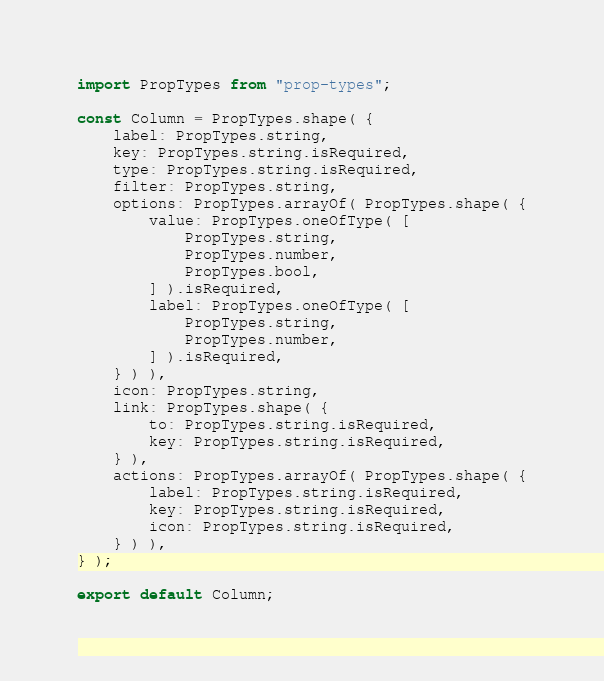Convert code to text. <code><loc_0><loc_0><loc_500><loc_500><_JavaScript_>import PropTypes from "prop-types";

const Column = PropTypes.shape( {
    label: PropTypes.string,
    key: PropTypes.string.isRequired,
    type: PropTypes.string.isRequired,
    filter: PropTypes.string,
    options: PropTypes.arrayOf( PropTypes.shape( {
        value: PropTypes.oneOfType( [
            PropTypes.string,
            PropTypes.number,
            PropTypes.bool,
        ] ).isRequired,
        label: PropTypes.oneOfType( [
            PropTypes.string,
            PropTypes.number,
        ] ).isRequired,
    } ) ),
    icon: PropTypes.string,
    link: PropTypes.shape( {
        to: PropTypes.string.isRequired,
        key: PropTypes.string.isRequired,
    } ),
    actions: PropTypes.arrayOf( PropTypes.shape( {
        label: PropTypes.string.isRequired,
        key: PropTypes.string.isRequired,
        icon: PropTypes.string.isRequired,
    } ) ),
} );

export default Column;
</code> 